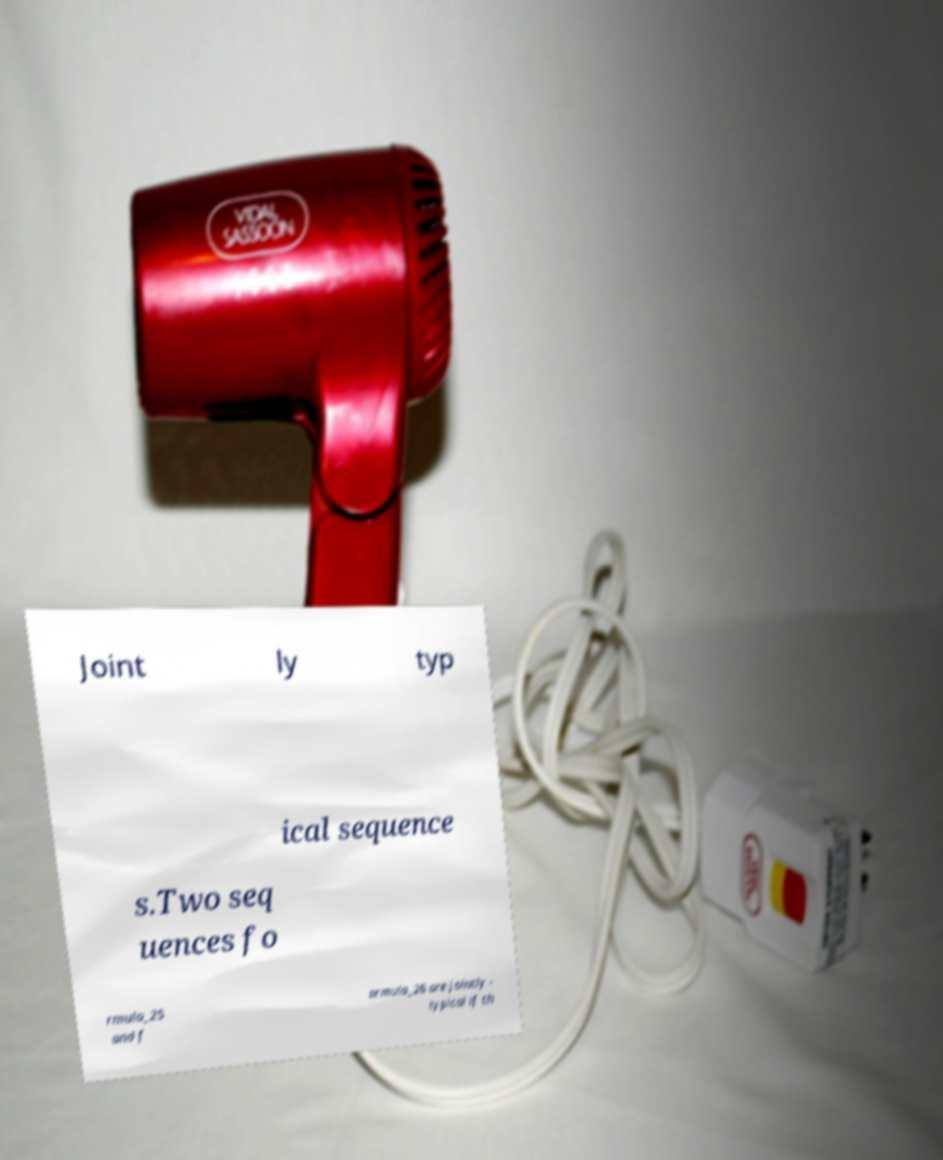Can you accurately transcribe the text from the provided image for me? Joint ly typ ical sequence s.Two seq uences fo rmula_25 and f ormula_26 are jointly - typical if th 